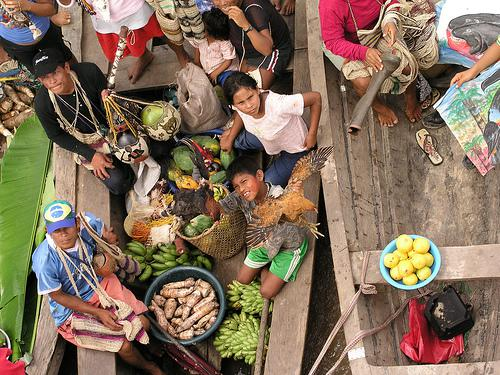Question: why are they looking up?
Choices:
A. Birds.
B. Planes.
C. The camera.
D. Kites.
Answer with the letter. Answer: C Question: what is flying?
Choices:
A. Grackle.
B. Crow.
C. Stork.
D. Chicken.
Answer with the letter. Answer: D Question: where was the picture taken?
Choices:
A. In car.
B. On a boat.
C. On plane.
D. On Train.
Answer with the letter. Answer: B 